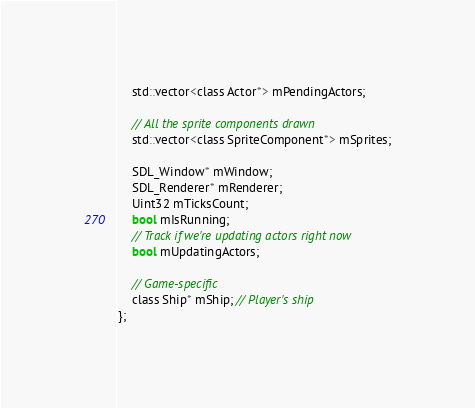<code> <loc_0><loc_0><loc_500><loc_500><_C_>	std::vector<class Actor*> mPendingActors;

	// All the sprite components drawn
	std::vector<class SpriteComponent*> mSprites;

	SDL_Window* mWindow;
	SDL_Renderer* mRenderer;
	Uint32 mTicksCount;
	bool mIsRunning;
	// Track if we're updating actors right now
	bool mUpdatingActors;

	// Game-specific
	class Ship* mShip; // Player's ship
};
</code> 